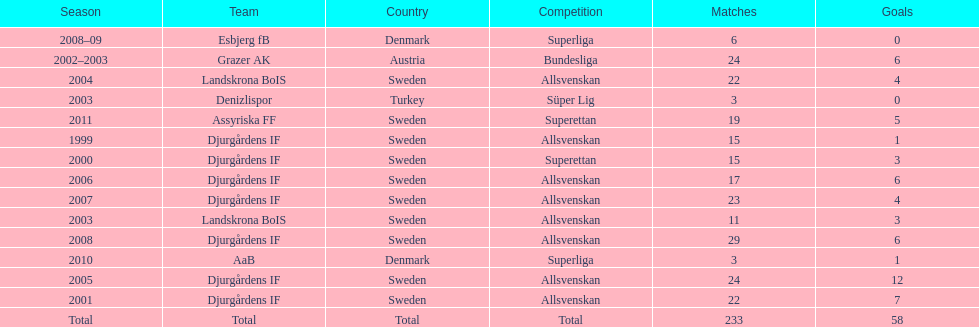What season has the most goals? 2005. 